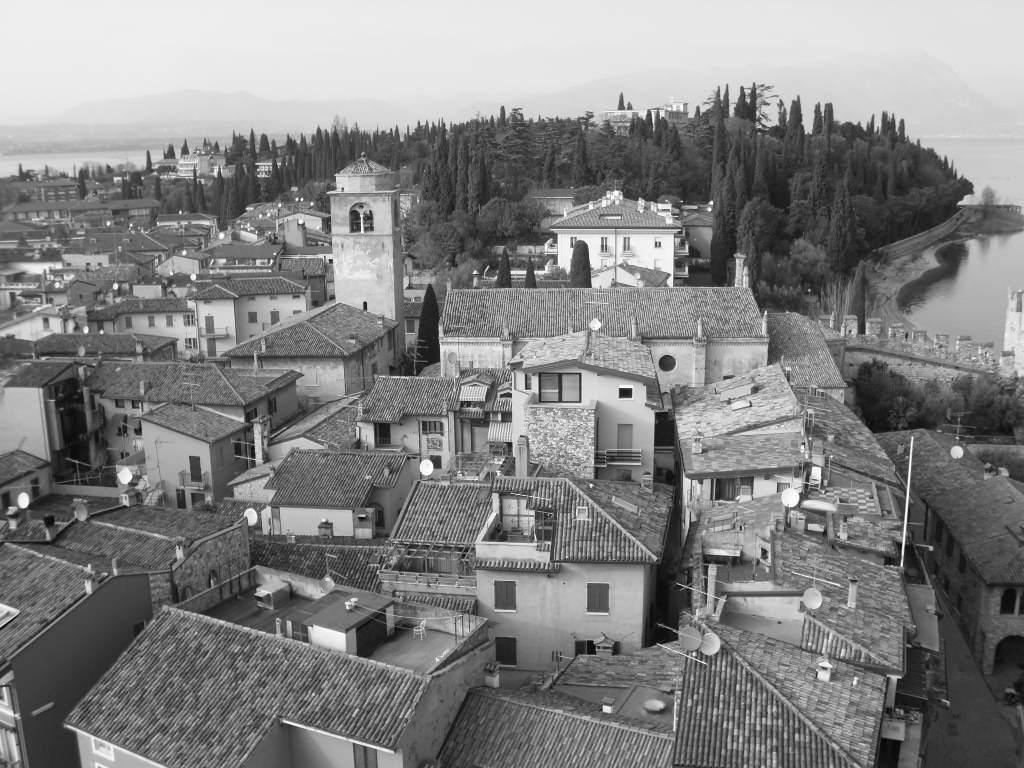What type of structures are present in the image? There are buildings in the image. What feature can be seen on the buildings? There are windows in the image. What type of natural elements are visible in the image? There are trees in the image. How is the image presented in terms of color? The image is black and white in color. What type of bread can be seen being distributed during the protest in the image? There is no protest or bread present in the image; it features buildings, windows, trees, and is black and white in color. 